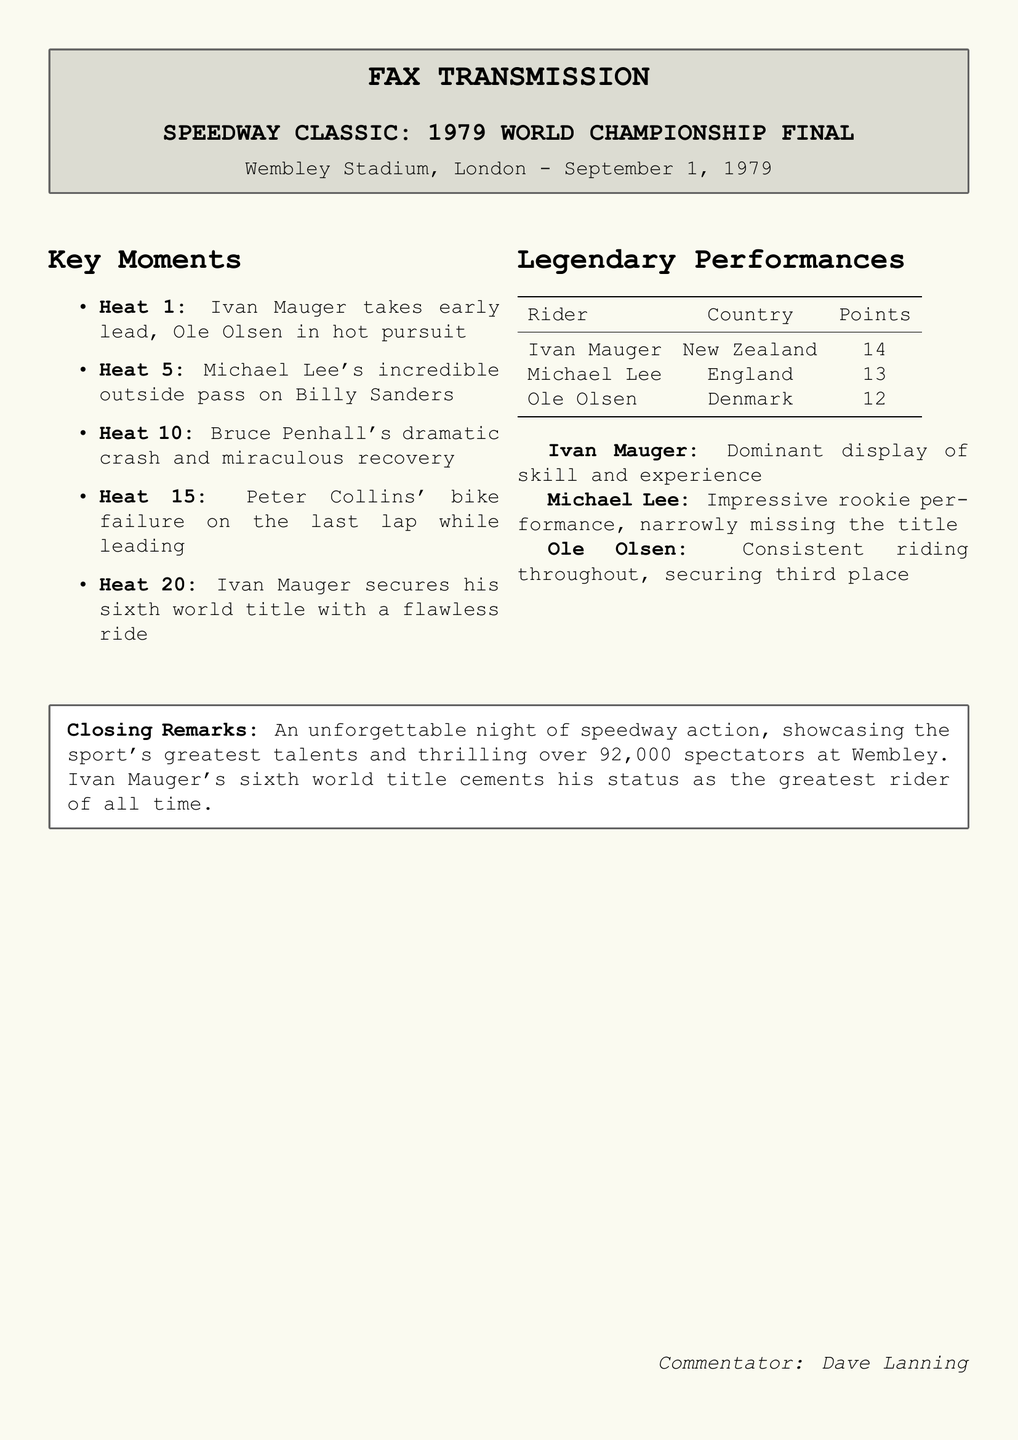what year did the championship final take place? The document specifically states that the championship final occurred on September 1, 1979.
Answer: 1979 who took the early lead in Heat 1? The document mentions that Ivan Mauger took the early lead in Heat 1.
Answer: Ivan Mauger which rider had a dramatic crash in Heat 10? According to the key moments, Bruce Penhall had a dramatic crash in Heat 10.
Answer: Bruce Penhall how many points did Michael Lee score? The tabular data in the document shows that Michael Lee scored 13 points.
Answer: 13 what was significant about Ivan Mauger's performance? The commentary highlights Ivan Mauger's dominant display of skill and experience throughout the race.
Answer: Dominant display who experienced a bike failure on the last lap of Heat 15? The document states that Peter Collins experienced a bike failure while leading in Heat 15.
Answer: Peter Collins how many spectators were present at Wembley Stadium for the event? The closing remarks note that over 92,000 spectators were present at the event.
Answer: 92,000 which country did Ole Olsen represent? The table lists Ole Olsen's country as Denmark.
Answer: Denmark what was the outcome for Michael Lee in the championship? The text notes that Michael Lee was an impressive rookie narrowly missing the title.
Answer: Narrowly missing the title 